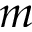<formula> <loc_0><loc_0><loc_500><loc_500>m</formula> 